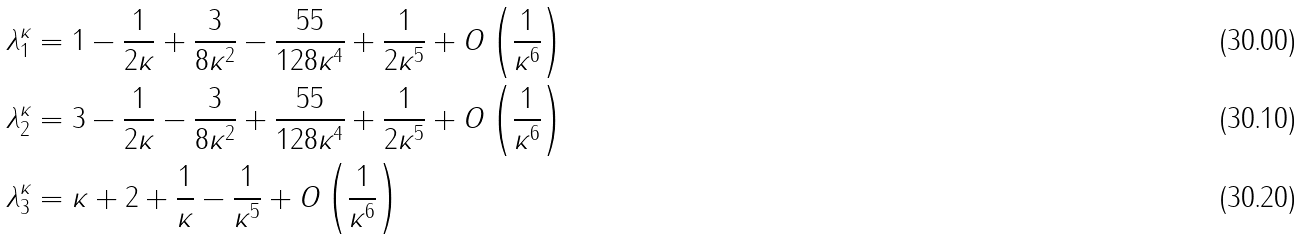Convert formula to latex. <formula><loc_0><loc_0><loc_500><loc_500>\lambda _ { 1 } ^ { \kappa } & = 1 - \frac { 1 } { 2 \kappa } + \frac { 3 } { 8 \kappa ^ { 2 } } - \frac { 5 5 } { 1 2 8 \kappa ^ { 4 } } + \frac { 1 } { 2 \kappa ^ { 5 } } + O \left ( \frac { 1 } { \kappa ^ { 6 } } \right ) \\ \lambda _ { 2 } ^ { \kappa } & = 3 - \frac { 1 } { 2 \kappa } - \frac { 3 } { 8 \kappa ^ { 2 } } + \frac { 5 5 } { 1 2 8 \kappa ^ { 4 } } + \frac { 1 } { 2 \kappa ^ { 5 } } + O \left ( \frac { 1 } { \kappa ^ { 6 } } \right ) \\ \lambda _ { 3 } ^ { \kappa } & = \kappa + 2 + \frac { 1 } { \kappa } - \frac { 1 } { \kappa ^ { 5 } } + O \left ( \frac { 1 } { \kappa ^ { 6 } } \right )</formula> 